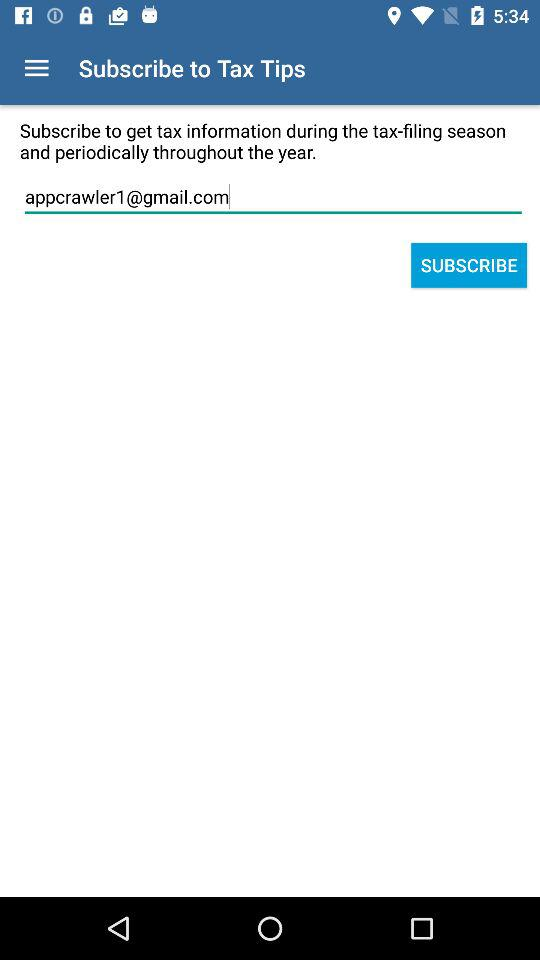Whose email is this?
When the provided information is insufficient, respond with <no answer>. <no answer> 